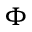<formula> <loc_0><loc_0><loc_500><loc_500>\Phi</formula> 